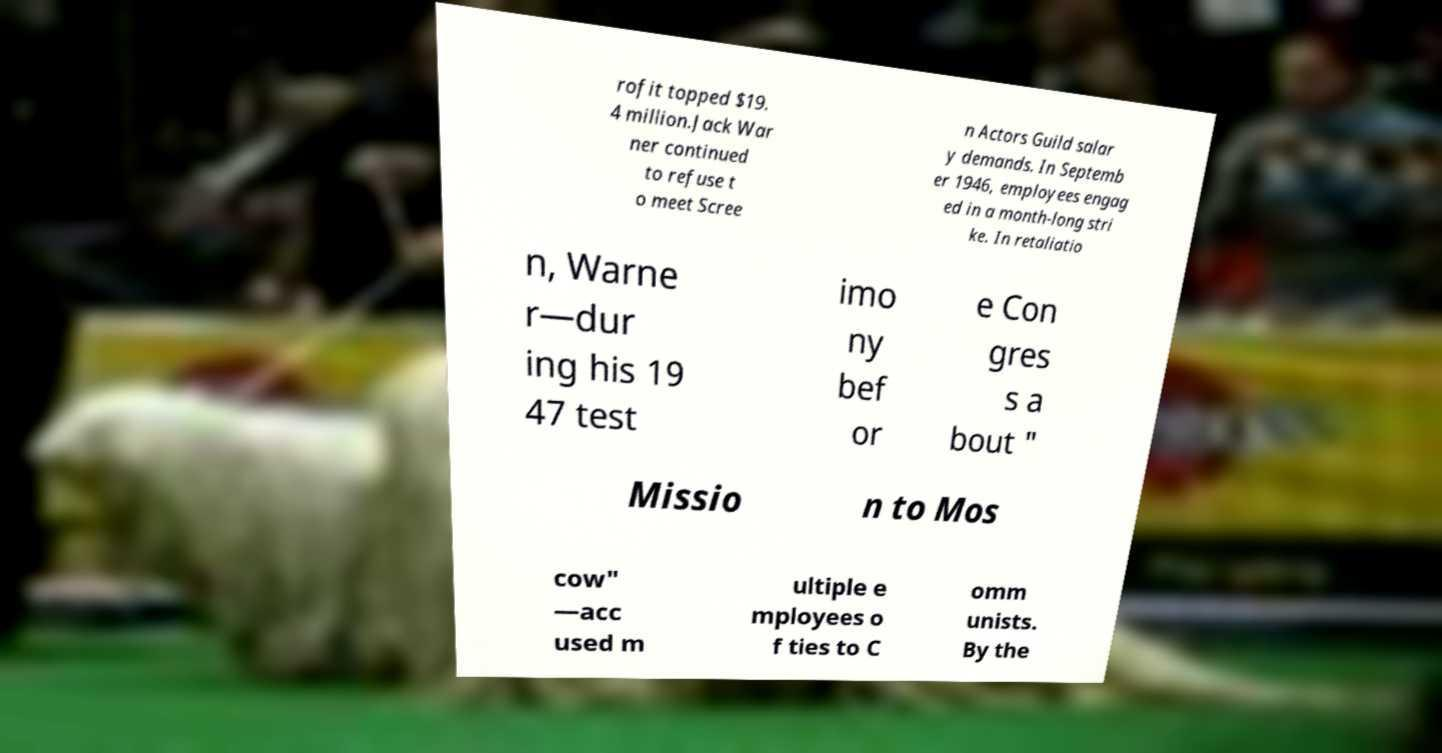Can you read and provide the text displayed in the image?This photo seems to have some interesting text. Can you extract and type it out for me? rofit topped $19. 4 million.Jack War ner continued to refuse t o meet Scree n Actors Guild salar y demands. In Septemb er 1946, employees engag ed in a month-long stri ke. In retaliatio n, Warne r—dur ing his 19 47 test imo ny bef or e Con gres s a bout " Missio n to Mos cow" —acc used m ultiple e mployees o f ties to C omm unists. By the 